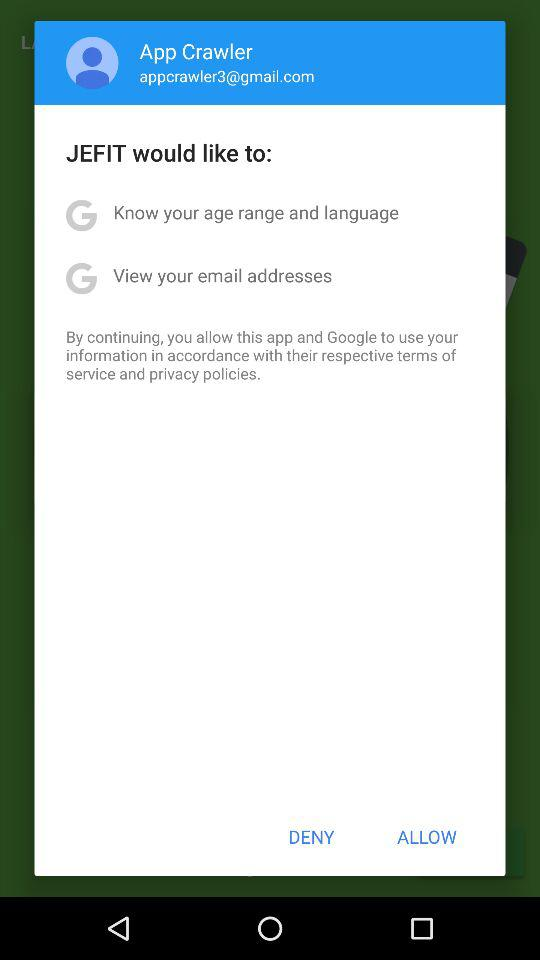How many permissions are being requested by JEFIT?
Answer the question using a single word or phrase. 2 